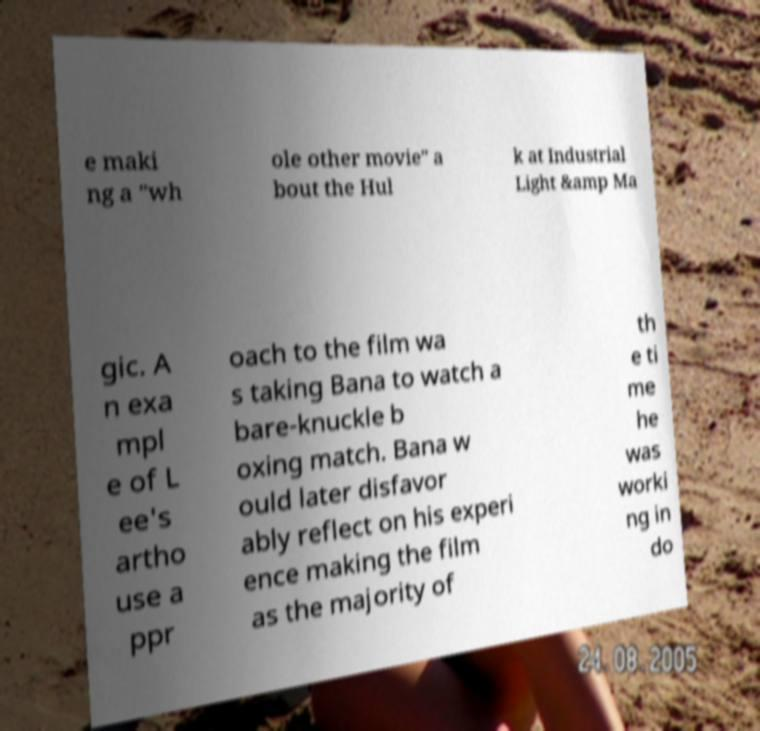Could you assist in decoding the text presented in this image and type it out clearly? e maki ng a "wh ole other movie" a bout the Hul k at Industrial Light &amp Ma gic. A n exa mpl e of L ee's artho use a ppr oach to the film wa s taking Bana to watch a bare-knuckle b oxing match. Bana w ould later disfavor ably reflect on his experi ence making the film as the majority of th e ti me he was worki ng in do 